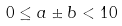<formula> <loc_0><loc_0><loc_500><loc_500>0 \leq a \pm b < 1 0</formula> 